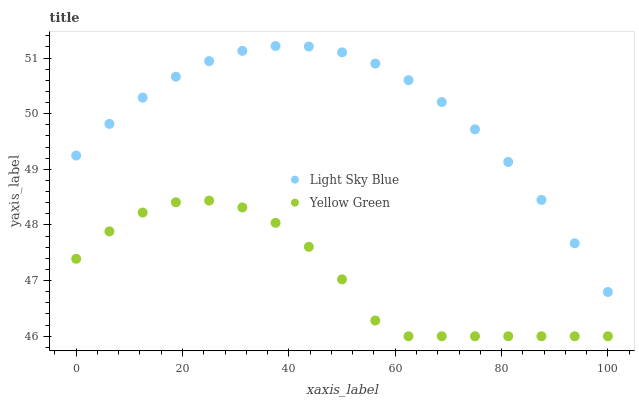Does Yellow Green have the minimum area under the curve?
Answer yes or no. Yes. Does Light Sky Blue have the maximum area under the curve?
Answer yes or no. Yes. Does Yellow Green have the maximum area under the curve?
Answer yes or no. No. Is Light Sky Blue the smoothest?
Answer yes or no. Yes. Is Yellow Green the roughest?
Answer yes or no. Yes. Is Yellow Green the smoothest?
Answer yes or no. No. Does Yellow Green have the lowest value?
Answer yes or no. Yes. Does Light Sky Blue have the highest value?
Answer yes or no. Yes. Does Yellow Green have the highest value?
Answer yes or no. No. Is Yellow Green less than Light Sky Blue?
Answer yes or no. Yes. Is Light Sky Blue greater than Yellow Green?
Answer yes or no. Yes. Does Yellow Green intersect Light Sky Blue?
Answer yes or no. No. 